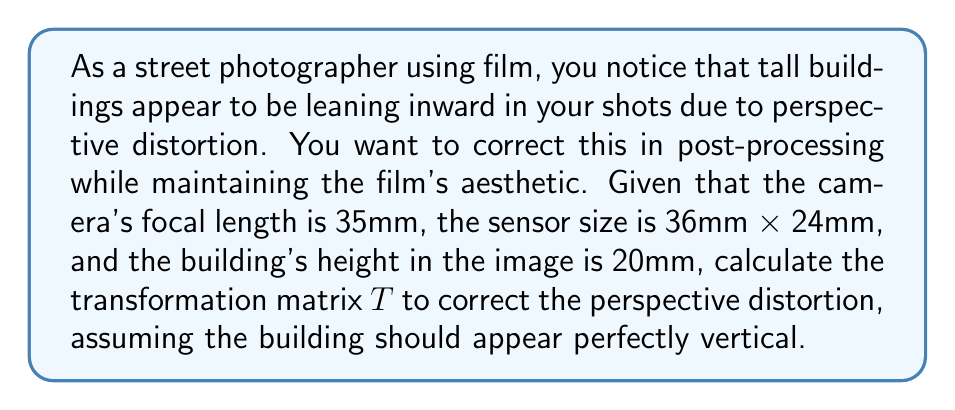Teach me how to tackle this problem. To correct perspective distortion, we need to calculate a transformation matrix that will map the distorted image points to their corrected positions. Let's approach this step-by-step:

1) First, we need to determine the angle of view (θ) based on the focal length and sensor size:

   $$\theta = 2 \arctan(\frac{\text{sensor height}}{2f}) = 2 \arctan(\frac{24}{2 \cdot 35}) \approx 37.8°$$

2) Next, we calculate the angle of distortion (α) based on the building's height in the image:

   $$\alpha = \arctan(\frac{\text{building height in image}}{\text{sensor height}}) = \arctan(\frac{20}{24}) \approx 39.8°$$

3) The perspective correction factor (k) is the ratio of these angles:

   $$k = \frac{\tan(\alpha)}{\tan(\theta/2)} \approx 1.84$$

4) Now we can construct the transformation matrix $T$. For perspective correction, we use a projective transformation matrix of the form:

   $$T = \begin{bmatrix}
   1 & 0 & 0 \\
   0 & k & 0 \\
   0 & p & 1
   \end{bmatrix}$$

   where $p$ is the perspective correction parameter.

5) To find $p$, we use the relation:

   $$p = \frac{k-1}{h}$$

   where $h$ is the normalized height of the image (1 in this case).

   $$p = 1.84 - 1 = 0.84$$

6) Therefore, our final transformation matrix $T$ is:

   $$T = \begin{bmatrix}
   1 & 0 & 0 \\
   0 & 1.84 & 0 \\
   0 & 0.84 & 1
   \end{bmatrix}$$

This matrix $T$ can be applied to the coordinates of each pixel in the original image to correct the perspective distortion.
Answer: $$T = \begin{bmatrix}
1 & 0 & 0 \\
0 & 1.84 & 0 \\
0 & 0.84 & 1
\end{bmatrix}$$ 